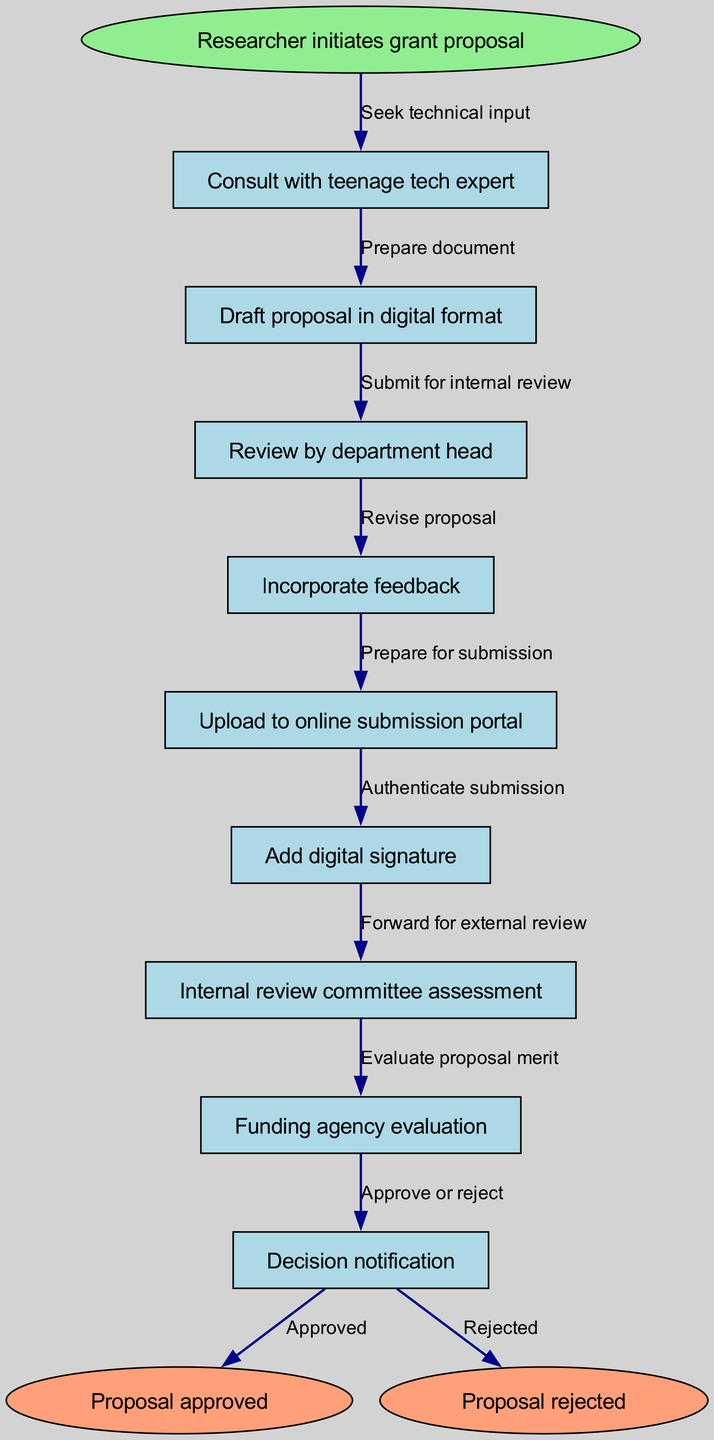What is the starting point of the diagram? The diagram begins with "Researcher initiates grant proposal," which is indicated as the start node.
Answer: Researcher initiates grant proposal How many nodes are in the diagram? The diagram includes 10 nodes total: 1 start node, 8 process nodes, and 1 end node.
Answer: 10 Which node follows "Consult with teenage tech expert"? Following "Consult with teenage tech expert," the next node is "Draft proposal in digital format." This is determined by tracing the flow from the start node.
Answer: Draft proposal in digital format What is the last step before the decision notification? The last step before reaching the "Decision notification" is "Funding agency evaluation," which comes right before it in the flow.
Answer: Funding agency evaluation What are the two outcomes represented at the end of the process? The two outcomes shown at the end of the process are "Proposal approved" and "Proposal rejected," which are the end nodes in the diagram.
Answer: Proposal approved and Proposal rejected How many edges are used to connect the nodes? There are 9 edges used in total to connect the nodes, starting from the initial action to the end nodes, indicating the flow of the process.
Answer: 9 What happens after "Incorporate feedback"? After "Incorporate feedback," the next action is "Upload to online submission portal." This follows the order presented in the flow diagram.
Answer: Upload to online submission portal What does "Add digital signature" signify in the process? "Add digital signature" signifies the step where the researcher authenticates the proposal before the submission process continues to external reviews.
Answer: Authentication of submission Which process directly leads to "Internal review committee assessment"? The process that directly leads to "Internal review committee assessment" is "Upload to online submission portal," as it is the action prior in the flow.
Answer: Upload to online submission portal 